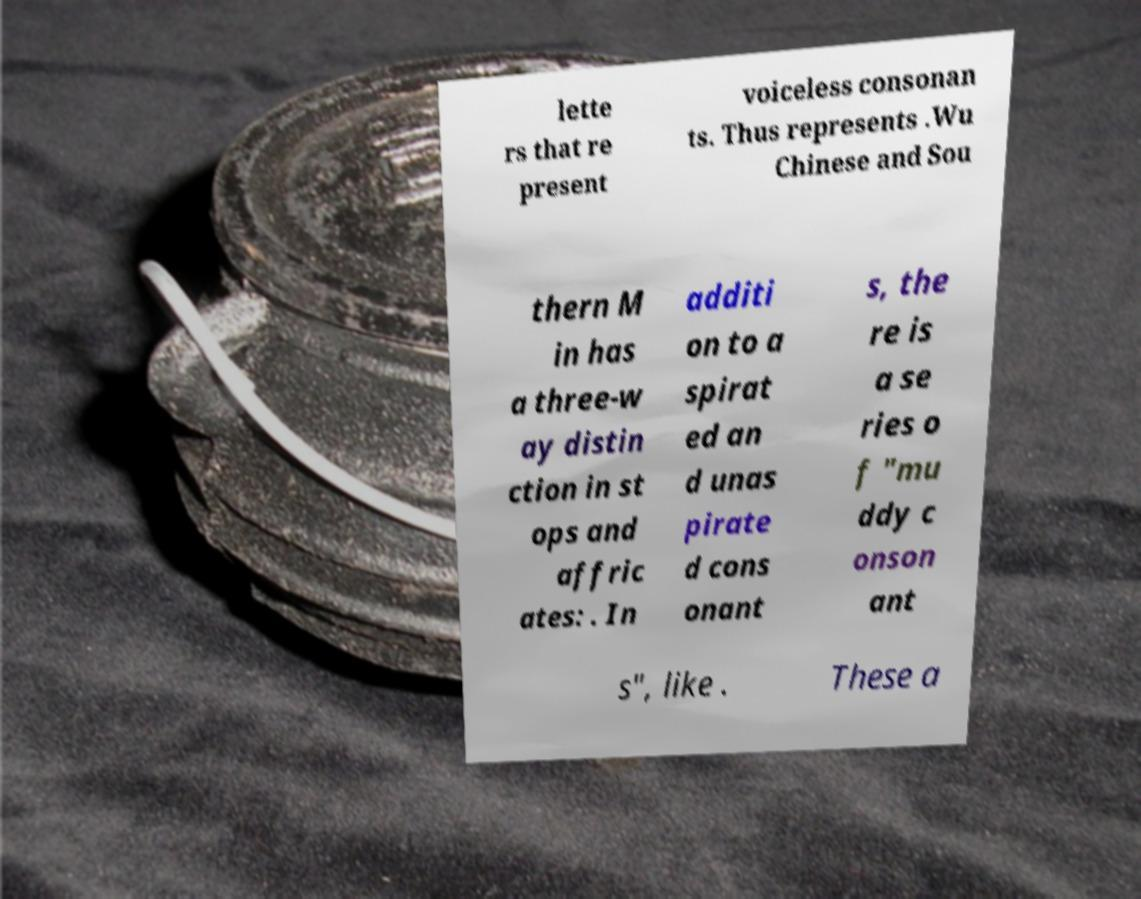There's text embedded in this image that I need extracted. Can you transcribe it verbatim? lette rs that re present voiceless consonan ts. Thus represents .Wu Chinese and Sou thern M in has a three-w ay distin ction in st ops and affric ates: . In additi on to a spirat ed an d unas pirate d cons onant s, the re is a se ries o f "mu ddy c onson ant s", like . These a 